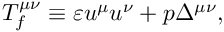Convert formula to latex. <formula><loc_0><loc_0><loc_500><loc_500>T _ { f } ^ { \mu \nu } \equiv \varepsilon u ^ { \mu } u ^ { \nu } + p \Delta ^ { \mu \nu } ,</formula> 